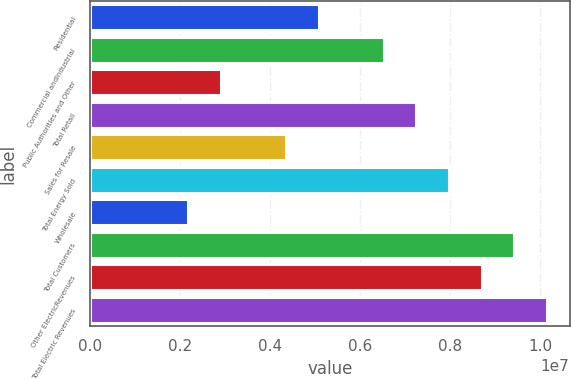Convert chart. <chart><loc_0><loc_0><loc_500><loc_500><bar_chart><fcel>Residential<fcel>Commercial andIndustrial<fcel>Public Authorities and Other<fcel>Total Retail<fcel>Sales for Resale<fcel>Total Energy Sold<fcel>Wholesale<fcel>Total Customers<fcel>Other ElectricRevenues<fcel>Total Electric Revenues<nl><fcel>5.07055e+06<fcel>6.51927e+06<fcel>2.89746e+06<fcel>7.24364e+06<fcel>4.34618e+06<fcel>7.968e+06<fcel>2.17309e+06<fcel>9.41673e+06<fcel>8.69236e+06<fcel>1.01411e+07<nl></chart> 